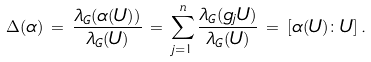<formula> <loc_0><loc_0><loc_500><loc_500>\Delta ( \alpha ) \, = \, \frac { \lambda _ { G } ( \alpha ( U ) ) } { \lambda _ { G } ( U ) } \, = \, \sum _ { j = 1 } ^ { n } \frac { \lambda _ { G } ( g _ { j } U ) } { \lambda _ { G } ( U ) } \, = \, [ \alpha ( U ) \colon U ] \, .</formula> 